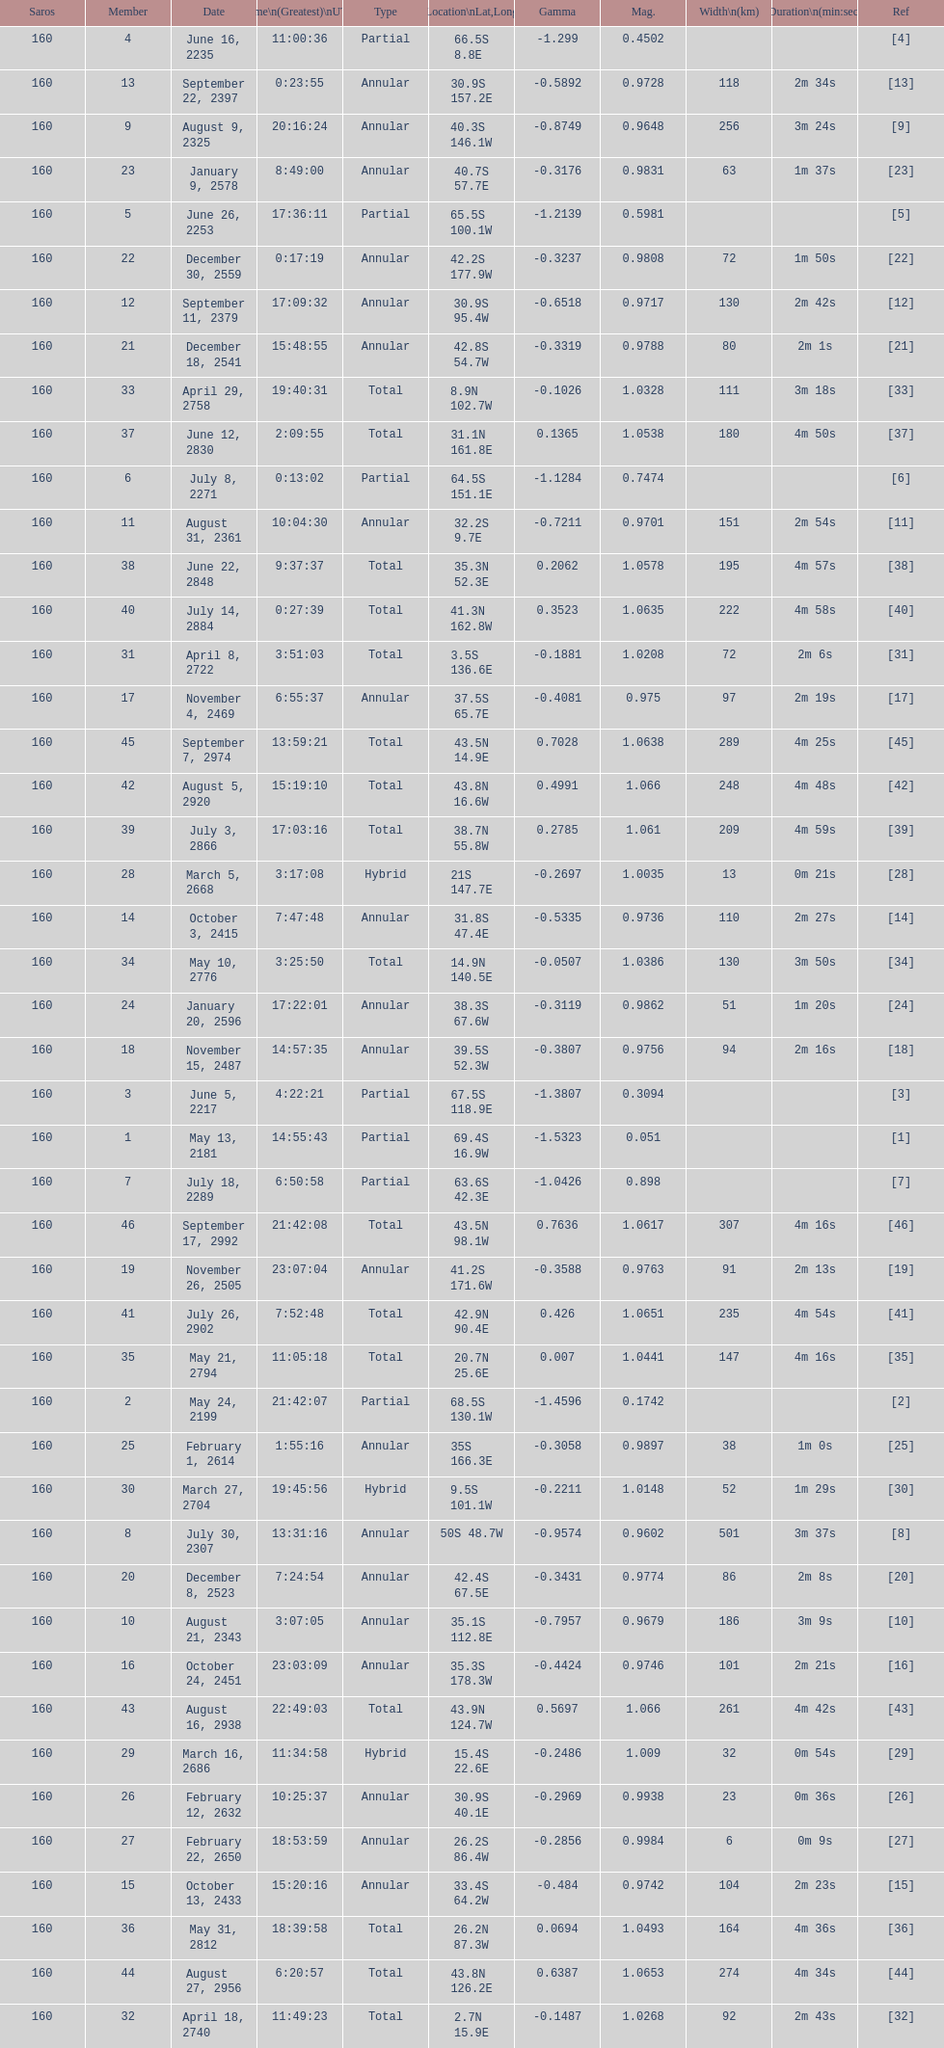Which one has a larger width, 8 or 21? 8. 